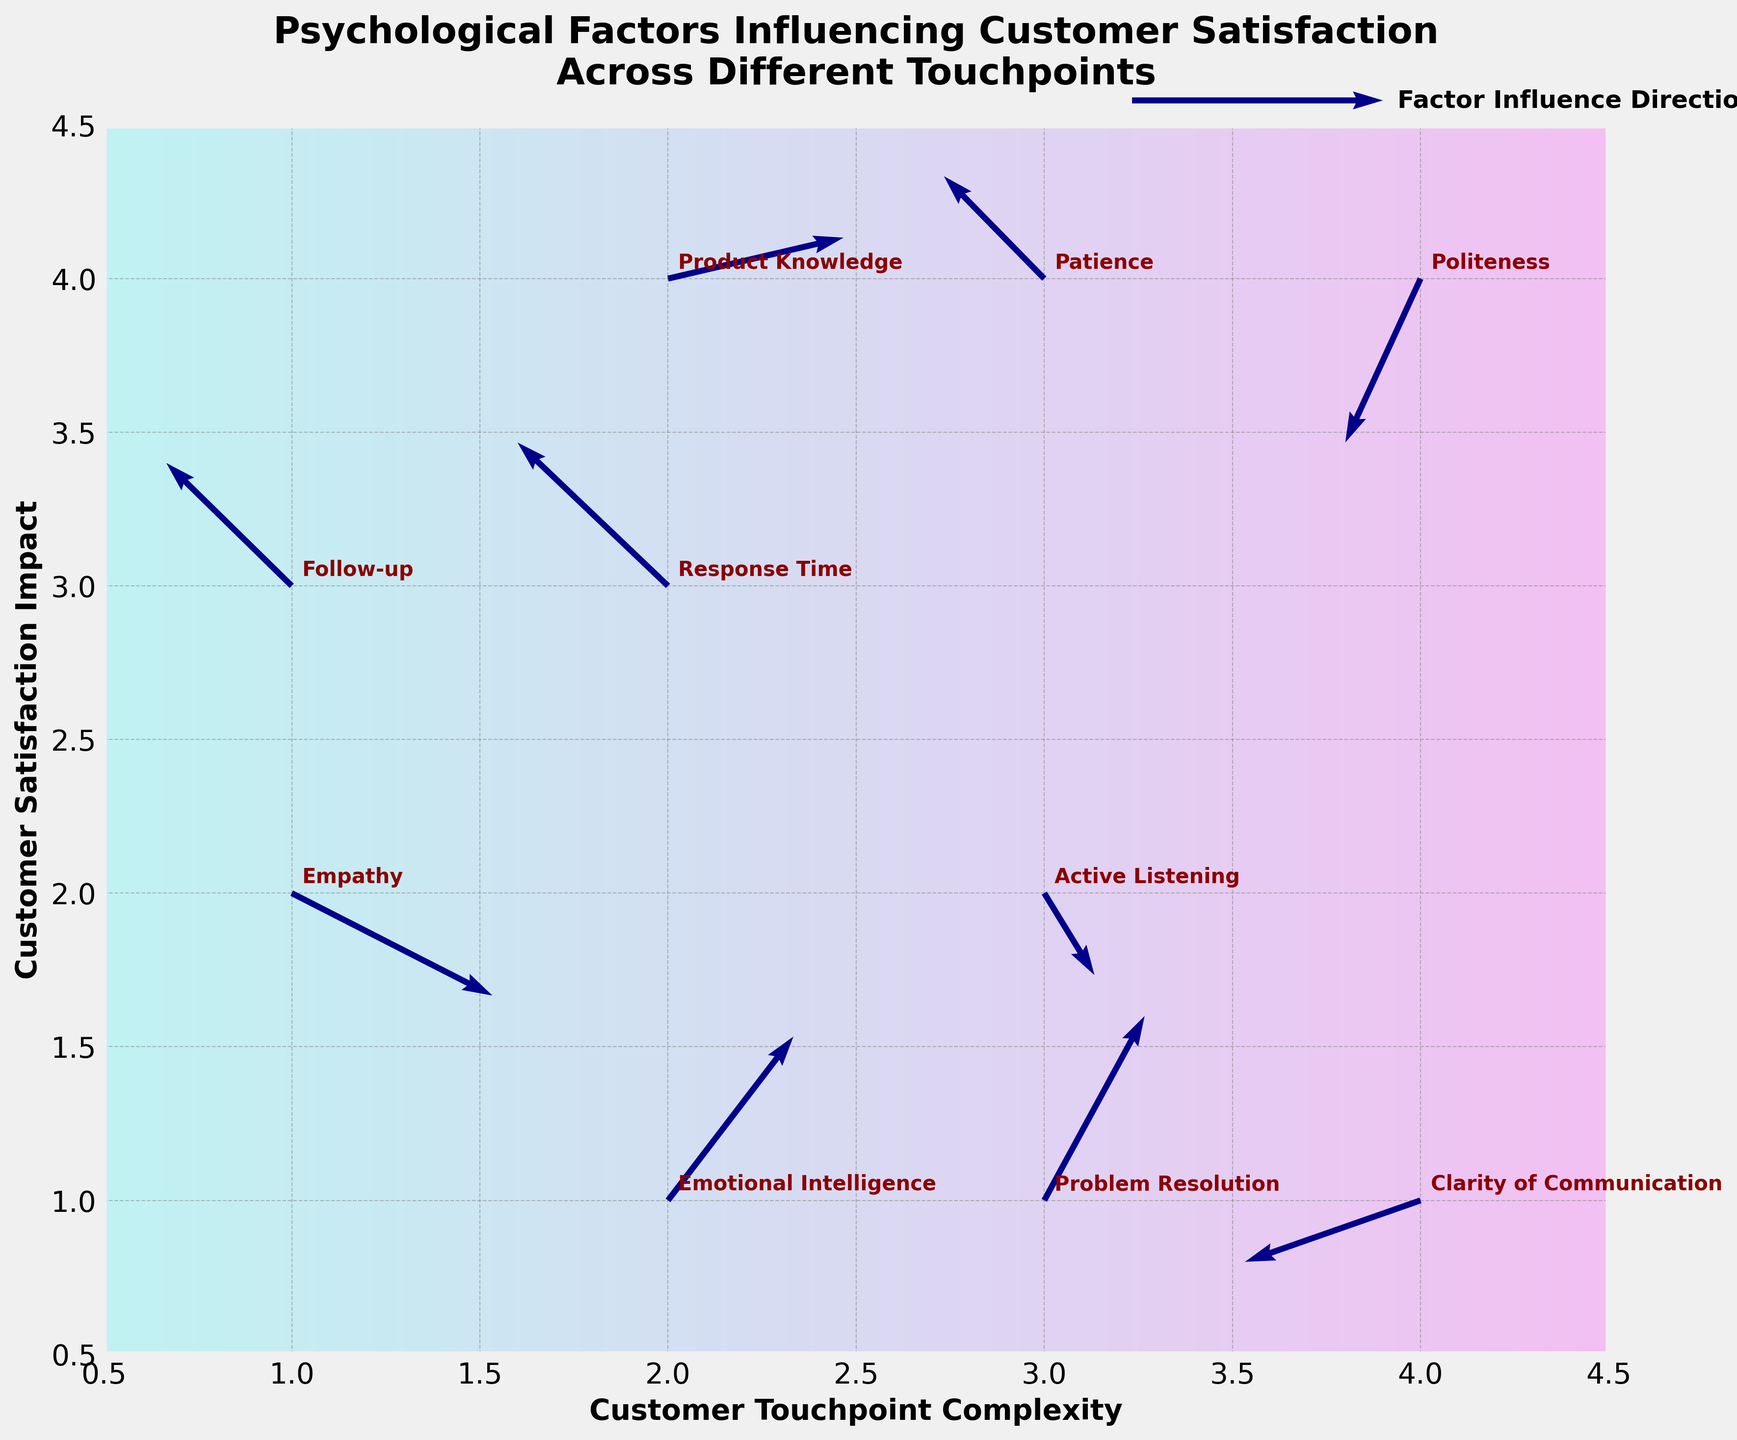what is the title of the plot? The title of the plot is situated at the top of the figure. It reads "Psychological Factors Influencing Customer Satisfaction Across Different Touchpoints".
Answer: Psychological Factors Influencing Customer Satisfaction Across Different Touchpoints how many data points are on the plot? The number of data points can be counted by identifying each arrow in the figure. There are 10 arrows representing different psychological factors.
Answer: 10 which psychological factor is located at (4,4)? By looking at the annotations on the figure, the arrow located at (4,4) represents the factor "Politeness".
Answer: Politeness what are the axis labels in the plot? The x-axis is labeled "Customer Touchpoint Complexity" and the y-axis is labeled "Customer Satisfaction Impact".
Answer: Customer Touchpoint Complexity, Customer Satisfaction Impact which factor has the highest positive impact on customer satisfaction? The factor with the highest positive impact on customer satisfaction will have the highest v value. "Problem Resolution" at (3,1) has the highest v value of 0.9, indicating the highest positive impact.
Answer: Problem Resolution does empathy tend to increase or decrease customer satisfaction? The direction of the arrow for Empathy, located at (1,2), needs to be examined. Its v value is -0.5 showing a downward direction, indicating it tends to decrease customer satisfaction.
Answer: Decrease which factor shows the strongest negative impact on customer satisfaction? The factor with the lowest v value will show the strongest negative impact. "Politeness" at (4,4) has the lowest v value of -0.8.
Answer: Politeness compare the direction and magnitude of the effect of "Emotional Intelligence" with "Response Time". Emotional Intelligence is represented by the arrow at (2,1) with (u=0.5, v=0.8), while Response Time is at (2,3) with (u=-0.6, v=0.7). Both factors have positive impacts (v values are positive), but Emotional Intelligence has a slightly greater influence vertically (0.8 vs 0.7).
Answer: Emotional Intelligence has a greater impact is the vector representing Active Listening (3,2) more horizontal or vertical? By comparing the u and v values, Active Listening (3,2) has u=0.2 and v=-0.4. Since the magnitude of v is greater, the vector is more vertical.
Answer: Vertical between Product Knowledge and Follow-up, which factor increases touchpoint complexity more? Product Knowledge is at (2,4) with u=0.7 while Follow-up is at (1,3) with u=-0.5. u value for Product Knowledge indicates a higher increase in touchpoint complexity.
Answer: Product Knowledge 